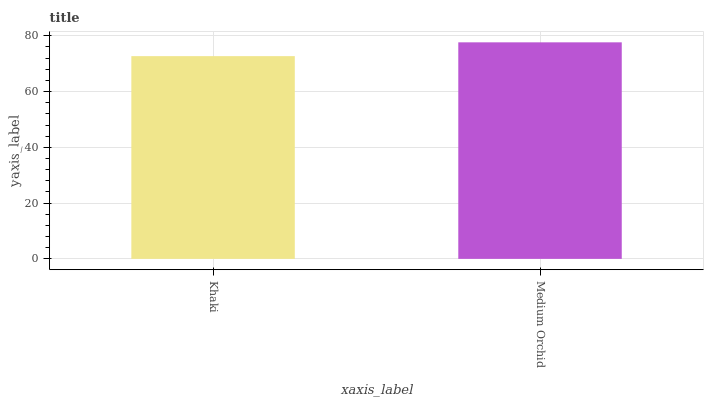Is Khaki the minimum?
Answer yes or no. Yes. Is Medium Orchid the maximum?
Answer yes or no. Yes. Is Medium Orchid the minimum?
Answer yes or no. No. Is Medium Orchid greater than Khaki?
Answer yes or no. Yes. Is Khaki less than Medium Orchid?
Answer yes or no. Yes. Is Khaki greater than Medium Orchid?
Answer yes or no. No. Is Medium Orchid less than Khaki?
Answer yes or no. No. Is Medium Orchid the high median?
Answer yes or no. Yes. Is Khaki the low median?
Answer yes or no. Yes. Is Khaki the high median?
Answer yes or no. No. Is Medium Orchid the low median?
Answer yes or no. No. 